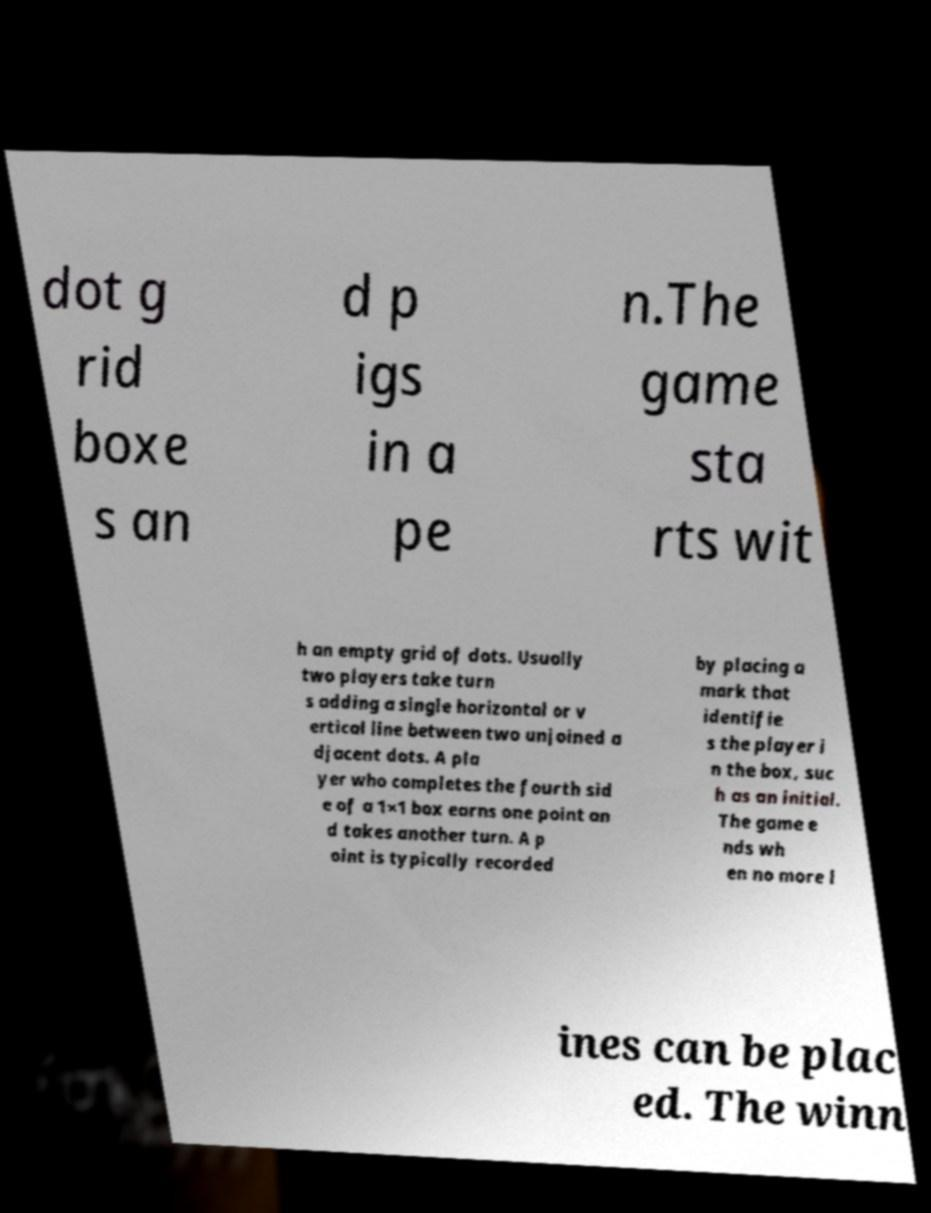Please identify and transcribe the text found in this image. dot g rid boxe s an d p igs in a pe n.The game sta rts wit h an empty grid of dots. Usually two players take turn s adding a single horizontal or v ertical line between two unjoined a djacent dots. A pla yer who completes the fourth sid e of a 1×1 box earns one point an d takes another turn. A p oint is typically recorded by placing a mark that identifie s the player i n the box, suc h as an initial. The game e nds wh en no more l ines can be plac ed. The winn 